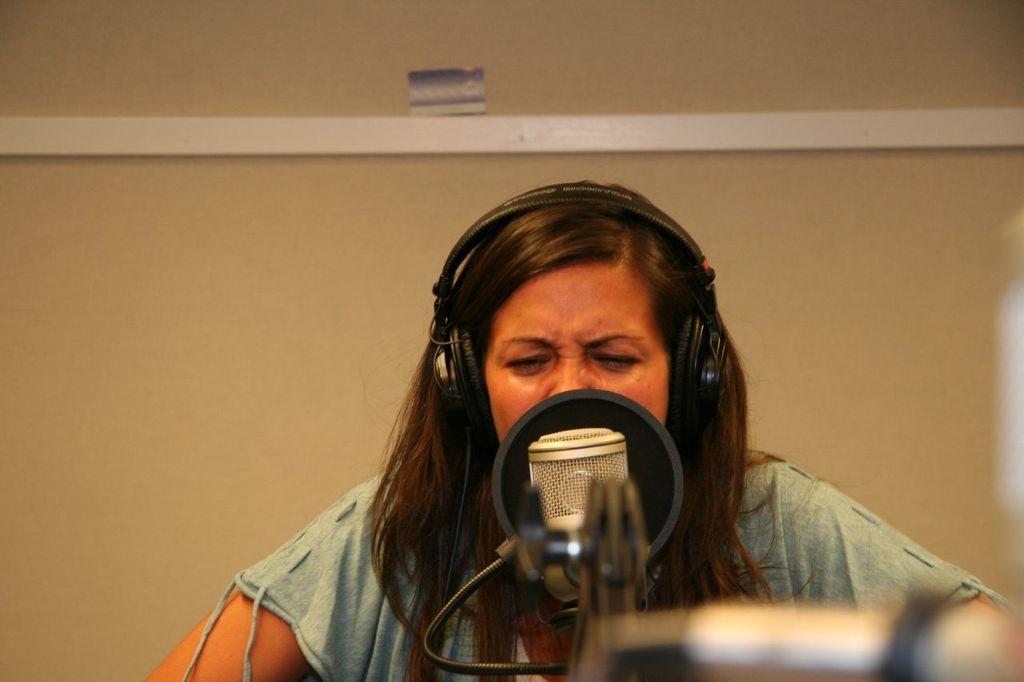How would you summarize this image in a sentence or two? In this picture we can see a woman, there is a microphone in front of her, she is wearing headphones, in the background there is a wall. 